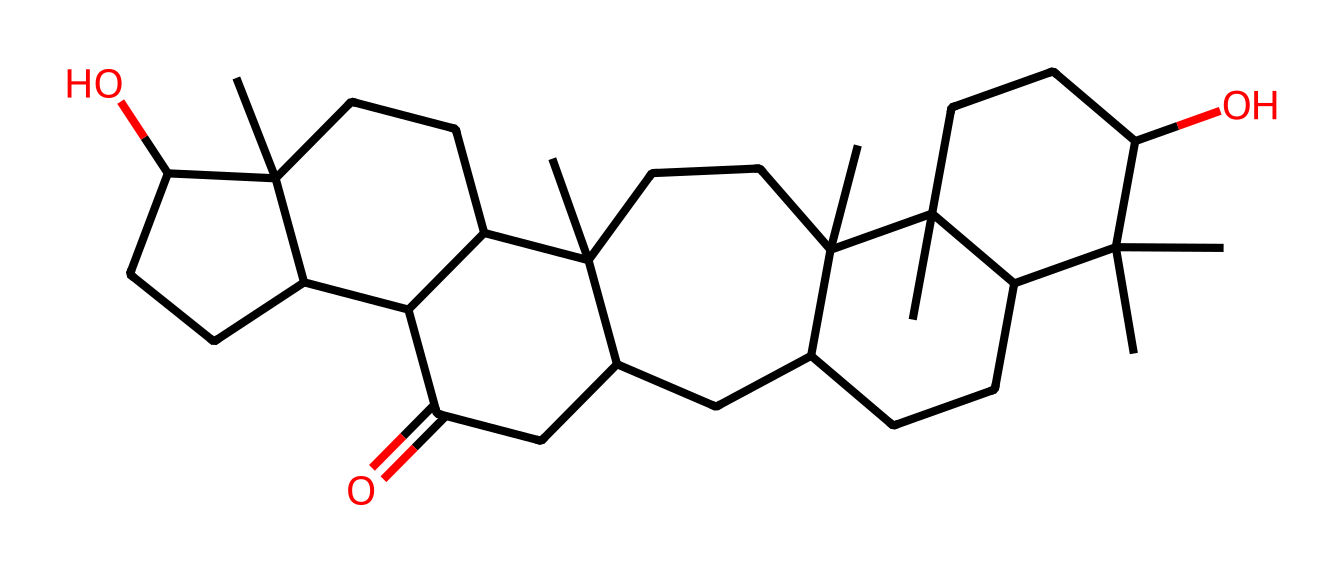What is the molecular formula of ginseng? To determine the molecular formula, count the number of each type of atom present in the SMILES representation. In this case, the molecule appears to consist primarily of carbon (C), hydrogen (H), and oxygen (O). By analyzing the structure, we find there are 30 carbon atoms, 50 hydrogen atoms, and 2 oxygen atoms. Therefore, the molecular formula is C30H50O2.
Answer: C30H50O2 How many rings are present in the ginseng structure? When examining the SMILES representation for cyclic structures, we look for the numbers used to indicate ring closures. In this molecule, there are three distinct ring closures indicated by the numbers ‘1’, ‘2’, and ‘3’. This shows there are 3 rings present in the molecular structure.
Answer: 3 What type of compound is ginseng primarily classified as? Given the structure is complex and has multiple rings and functional groups, it is a type of triterpenoid. Triterpenoids are typically characterized by their wide-ranging biological activities and structural complexity, which is evident in the ginseng molecule.
Answer: triterpenoid How many carbon atoms are branching from the main chain in the ginseng structure? Analyzing the SMILES representation, we identify branching points where carbon atoms extend from the main carbon chains. Upon counting, there are 7 carbon branches distinctly attached to the main scaffold of the structure.
Answer: 7 Does ginseng contain any hydroxyl groups? To determine the presence of hydroxyl groups (–OH), we should look for the letter 'O' in the SMILES representation, particularly those not involved in a carbonyl (C=O) functional group. In this case, there are 2 instances of ‘O’ integrated into the structure, indicating that there are hydroxyl groups present.
Answer: yes What is the implied stereochemistry of ginseng's structure? The stereochemistry can be inferred from the arrangement of the atoms and any potential chiral centers in the SMILES. The molecule is complex and likely contains several chiral centers due to its multi-layered rings and branched carbon chains. This complexity lends itself to stereoisomerism, though the exact stereochemical configuration is not detailed in the SMILES directly.
Answer: multiple chiral centers What functional group is suggested by the presence of the carbonyl in ginseng? In the provided SMILES, the presence of a carbonyl group (C=O) indicates that the compound has ketonic characteristics, typical of many bioactive compounds, including ginseng. This functional group is crucial for its biological activity, implying that ginseng contains ketonic functionality.
Answer: ketone 